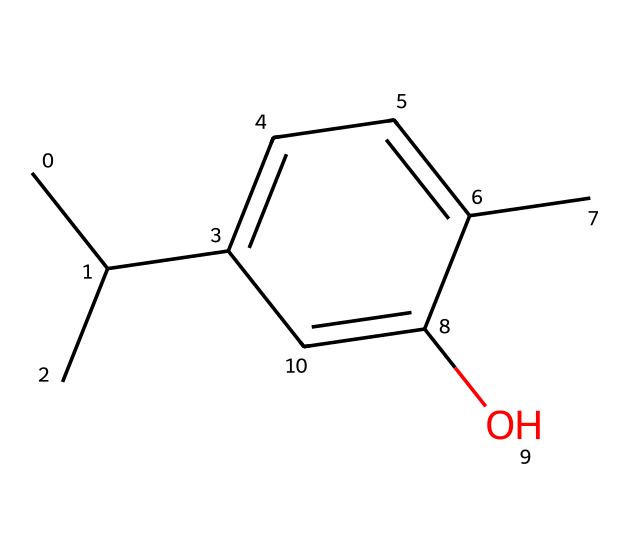What is the chemical name of the structure represented? The SMILES representation corresponds to thymol, which is a major component of thyme oil and acts as a natural fungicide.
Answer: thymol How many carbon atoms are in thymol? By analyzing the structure in the SMILES representation, we can count 10 carbon atoms, indicating its carbon backbone.
Answer: 10 What type of chemical bond connects the carbon atoms in thymol? The structure indicates multiple single bonds and at least one double bond (C=C), indicating the presence of both types of bonds among the carbon atoms.
Answer: single and double bonds What functional group is present in thymol? The hydroxyl group (-OH) indicated by the presence of "O" in the structure designates this compound as having a phenolic functional group, which is responsible for its antifungal properties.
Answer: hydroxyl Does thymol contain any rings in its structure? The presence of "C1" in the SMILES notation signifies a cyclohexane-like structure, confirming that there is a ring in the compound.
Answer: Yes What distinguishes thymol as a fungicide? The presence of the phenolic hydroxyl group enables thymol to disrupt fungal cell membranes, thus enhancing its efficacy as a natural fungicide.
Answer: phenolic hydroxyl group How many hydrogen atoms are associated with the structure of thymol? By considering the general formula for alkanes (C_nH_(2n+2)) adjusted for the double bond and functional groups, the total count of hydrogen atoms can be derived as 14 in thymol.
Answer: 14 